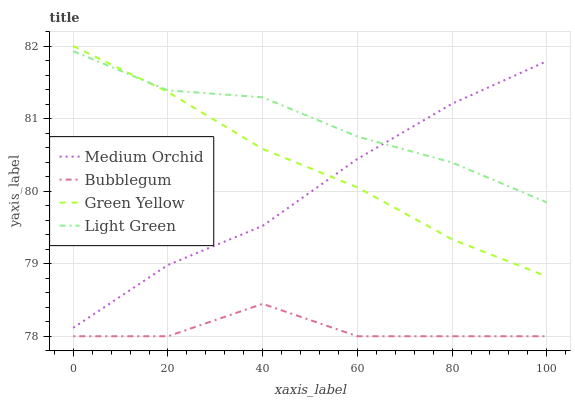Does Bubblegum have the minimum area under the curve?
Answer yes or no. Yes. Does Light Green have the maximum area under the curve?
Answer yes or no. Yes. Does Medium Orchid have the minimum area under the curve?
Answer yes or no. No. Does Medium Orchid have the maximum area under the curve?
Answer yes or no. No. Is Green Yellow the smoothest?
Answer yes or no. Yes. Is Bubblegum the roughest?
Answer yes or no. Yes. Is Medium Orchid the smoothest?
Answer yes or no. No. Is Medium Orchid the roughest?
Answer yes or no. No. Does Bubblegum have the lowest value?
Answer yes or no. Yes. Does Medium Orchid have the lowest value?
Answer yes or no. No. Does Green Yellow have the highest value?
Answer yes or no. Yes. Does Medium Orchid have the highest value?
Answer yes or no. No. Is Bubblegum less than Light Green?
Answer yes or no. Yes. Is Green Yellow greater than Bubblegum?
Answer yes or no. Yes. Does Green Yellow intersect Light Green?
Answer yes or no. Yes. Is Green Yellow less than Light Green?
Answer yes or no. No. Is Green Yellow greater than Light Green?
Answer yes or no. No. Does Bubblegum intersect Light Green?
Answer yes or no. No. 